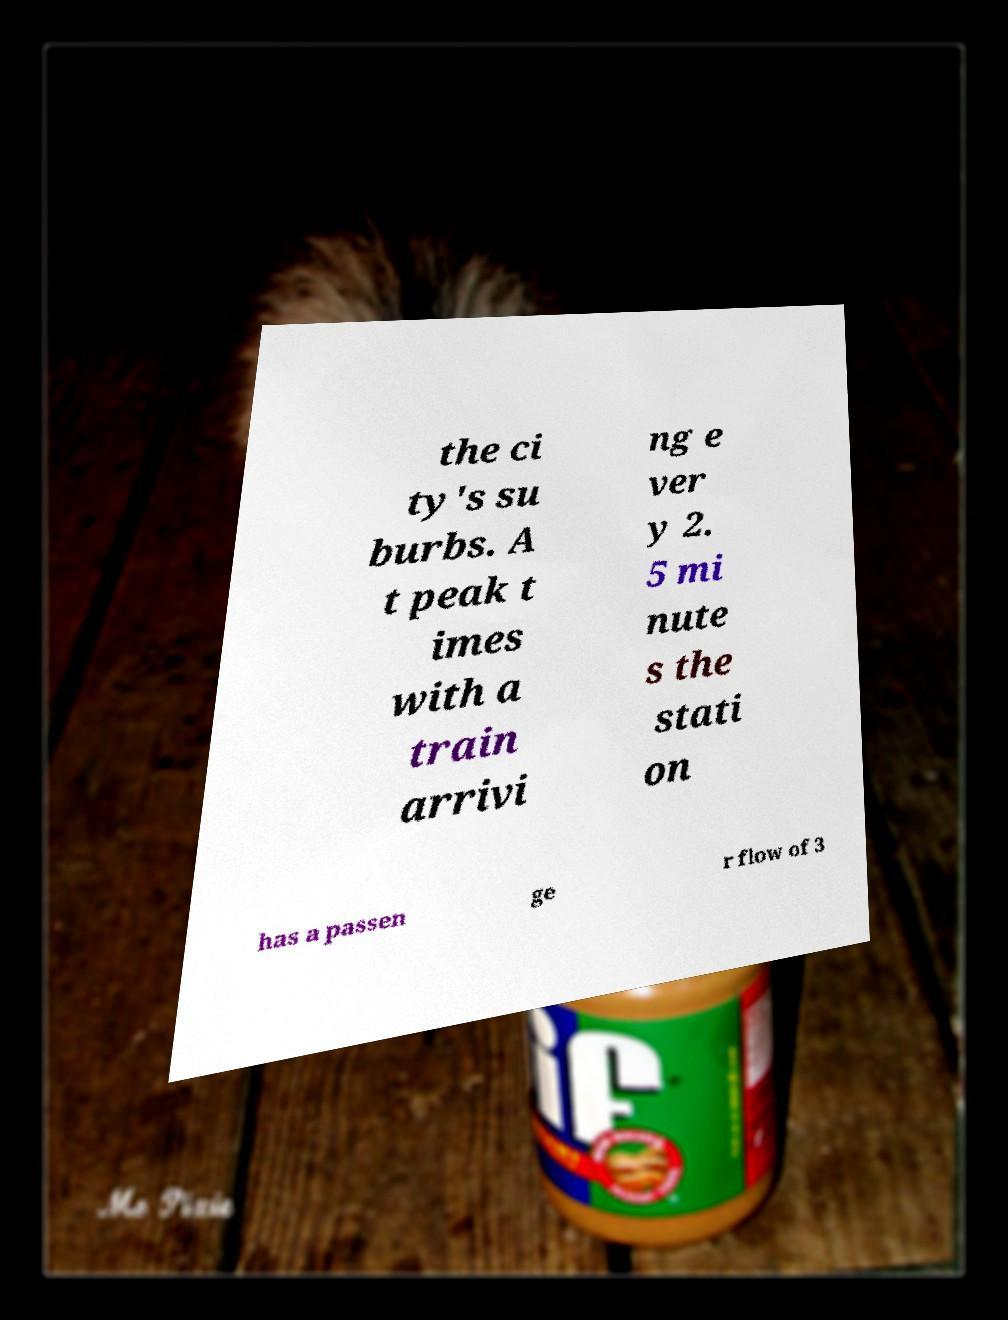Can you read and provide the text displayed in the image?This photo seems to have some interesting text. Can you extract and type it out for me? the ci ty's su burbs. A t peak t imes with a train arrivi ng e ver y 2. 5 mi nute s the stati on has a passen ge r flow of 3 